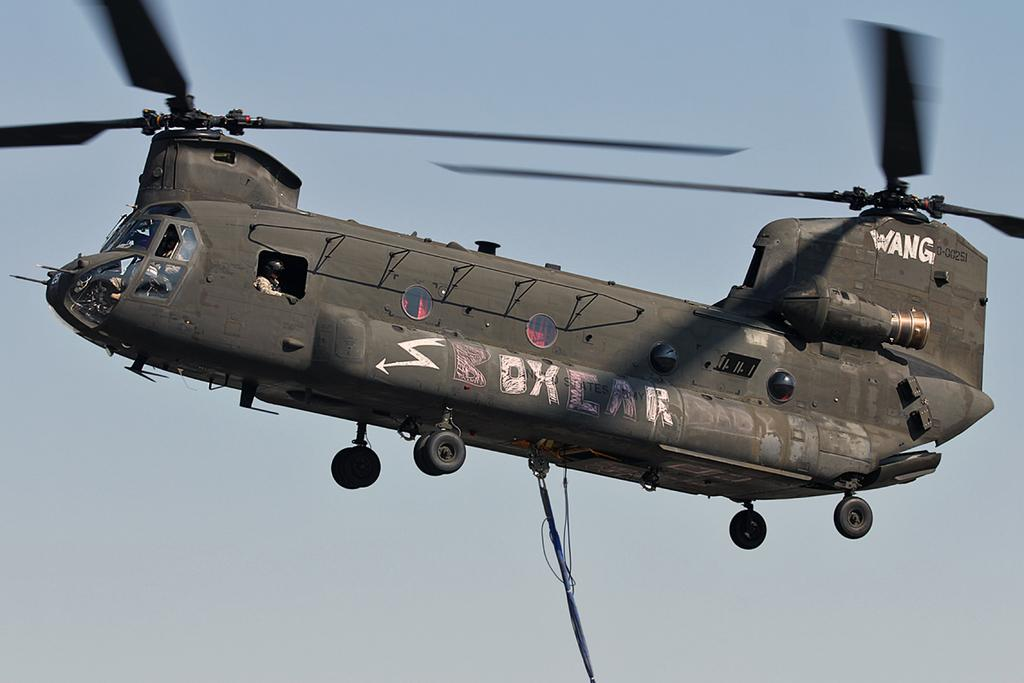<image>
Provide a brief description of the given image. a chinook helicopter with WANG written on the tail 